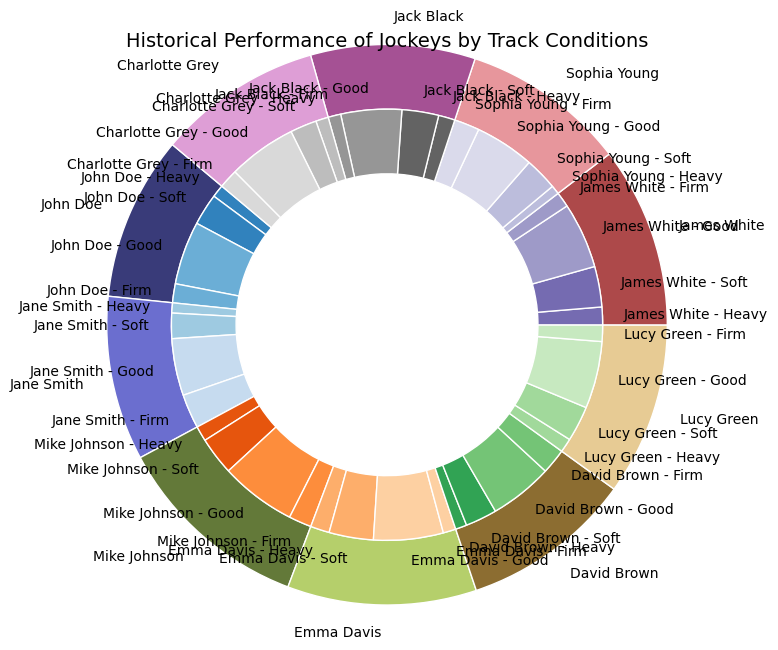Which jockey has the most wins on heavy track conditions? By looking at the inner pie chart slices representing "Heavy" track conditions and identifying the largest slice, we can determine the jockey with the most wins on heavy tracks. Emma Davis's segment is the largest.
Answer: Emma Davis Who has a greater number of wins on firm tracks, Jane Smith or David Brown? We compare the inner pie chart slices for "Firm" track conditions corresponding to Jane Smith and David Brown. Jane Smith's slice is larger than David Brown's.
Answer: Jane Smith What is the total number of wins for Mike Johnson across all track conditions? Sum the outer segment values for Mike Johnson, which are the sizes of the inner segments: 12 (Heavy) + 30 (Soft) + 60 (Good) + 18 (Firm).
Answer: 120 Among Lucy Green, James White, and Charlotte Grey, who has the highest number of wins on soft tracks? Compare the inner pie chart slices for "Soft" track conditions among Lucy Green, James White, and Charlotte Grey. James White's segment is the largest.
Answer: James White Which track condition shows John Doe performing most frequently? By examining the inner segments of John Doe's outer pie slice, the largest segment corresponds to "Good" track conditions.
Answer: Good Is Sophia Young more successful on soft tracks or heavy tracks? Compare the inner pie chart slices of Sophia Young for "Soft" and "Heavy" track conditions. "Soft" track segment for Sophia Young is larger than the "Heavy" track segment.
Answer: Soft Who has a higher number of total wins, Jack Black or Charlotte Grey? Sum the outer segment values (sizes of inner segments) for both Jack Black and Charlotte Grey. Jack Black: 13 + 29 + 48 + 10 = 100, Charlotte Grey: 10 + 21 + 54 + 15 = 100. Both have the same number.
Answer: They are equal What is the sum of wins on good tracks for John Doe and Emma Davis? Sum up the segments for "Good" track conditions for John Doe and Emma Davis: 50 (John Doe) + 55 (Emma Davis).
Answer: 105 Which jockey has the least number of wins on all track conditions combined? Identify the smallest outer pie segment among all the jockeys to find the one with the least total wins. Sophia Young’s outer segment is the smallest.
Answer: Sophia Young 